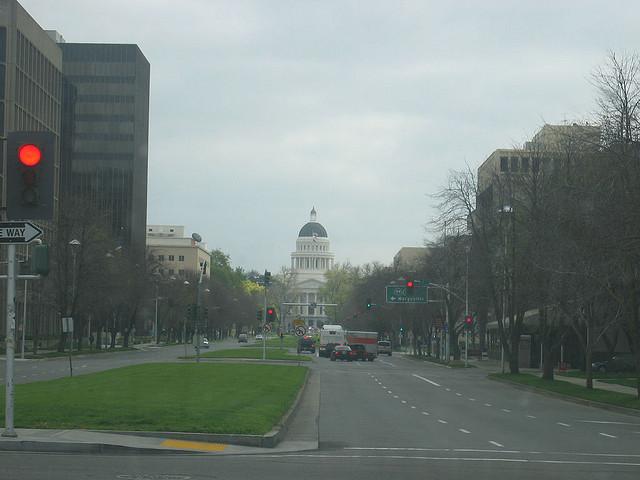Is the fog coming in?
Be succinct. Yes. Is the capital in the background?
Short answer required. Yes. How many traffic lights are red?
Answer briefly. 4. What color are the traffic lights on?
Write a very short answer. Red. Can you see any green grass?
Answer briefly. Yes. Is it snowing?
Keep it brief. No. What color are the traffic lights?
Give a very brief answer. Red. Should the car stop or go?
Give a very brief answer. Stop. Do some of the vehicles have their lights on?
Short answer required. Yes. 